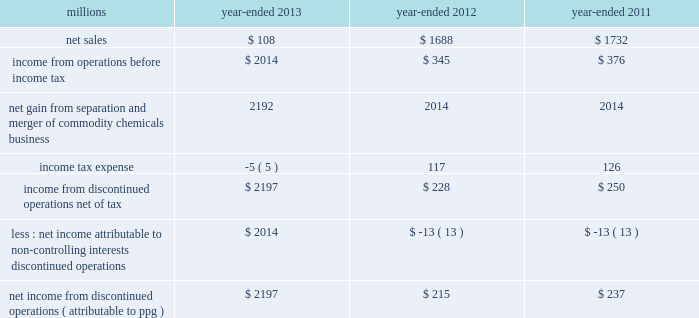74 2013 ppg annual report and form 10-k 22 .
Separation and merger transaction on january 28 , 2013 , the company completed the previously announced separation of its commodity chemicals business and merger of its wholly-owned subsidiary , eagle spinco inc. , with a subsidiary of georgia gulf corporation in a tax ef ficient reverse morris trust transaction ( the 201ctransaction 201d ) .
Pursuant to the merger , eagle spinco , the entity holding ppg's former commodity chemicals business , became a wholly-owned subsidiary of georgia gulf .
The closing of the merger followed the expiration of the related exchange offer and the satisfaction of certain other conditions .
The combined company formed by uniting georgia gulf with ppg's former commodity chemicals business is named axiall corporation ( 201caxiall 201d ) .
Ppg holds no ownership interest in axiall .
Ppg received the necessary ruling from the internal revenue service and as a result this transaction was generally tax free to ppg and its shareholders in the united states and canada .
Under the terms of the exchange offer , 35249104 shares of eagle spinco common stock were available for distribution in exchange for shares of ppg common stock accepted in the offer .
Following the merger , each share of eagle spinco common stock automatically converted into the right to receive one share of axiall corporation common stock .
Accordingly , ppg shareholders who tendered their shares of ppg common stock as part of this offer received 3.2562 shares of axiall common stock for each share of ppg common stock accepted for exchange .
Ppg was able to accept the maximum of 10825227 shares of ppg common stock for exchange in the offer , and thereby , reduced its outstanding shares by approximately 7% ( 7 % ) .
The completion of this exchange offer was a non-cash financing transaction , which resulted in an increase in "treasury stock" at a cost of $ 1.561 billion based on the ppg closing stock price on january 25 , 2013 .
Under the terms of the transaction , ppg received $ 900 million of cash and 35.2 million shares of axiall common stock ( market value of $ 1.8 billion on january 25 , 2013 ) which was distributed to ppg shareholders by the exchange offer as described above .
In addition , ppg received $ 67 million in cash for a preliminary post-closing working capital adjustment under the terms of the transaction agreements .
The net assets transferred to axiall included $ 27 million of cash on the books of the business transferred .
In the transaction , ppg transferred environmental remediation liabilities , defined benefit pension plan assets and liabilities and other post-employment benefit liabilities related to the commodity chemicals business to axiall .
During the first quarter of 2013 , ppg recorded a gain of $ 2.2 billion on the transaction reflecting the excess of the sum of the cash proceeds received and the cost ( closing stock price on january 25 , 2013 ) of the ppg shares tendered and accepted in the exchange for the 35.2 million shares of axiall common stock over the net book value of the net assets of ppg's former commodity chemicals business .
The transaction resulted in a net partial settlement loss of $ 33 million associated with the spin out and termination of defined benefit pension liabilities and the transfer of other post-retirement benefit liabilities under the terms of the transaction .
The company also incurred $ 14 million of pretax expense , primarily for professional services related to the transaction in 2013 as well as approximately $ 2 million of net expense related to certain retained obligations and post-closing adjustments under the terms of the transaction agreements .
The net gain on the transaction includes these related losses and expenses .
The results of operations and cash flows of ppg's former commodity chemicals business for january 2013 and the net gain on the transaction are reported as results from discontinued operations for the year -ended december 31 , 2013 .
In prior periods presented , the results of operations and cash flows of ppg's former commodity chemicals business have been reclassified from continuing operations and presented as results from discontinued operations .
Ppg will provide axiall with certain transition services for up to 24 months following the closing date of the transaction .
These services include logistics , purchasing , finance , information technology , human resources , tax and payroll processing .
The net sales and income before income taxes of the commodity chemicals business that have been reclassified and reported as discontinued operations are presented in the table below: .
Income from discontinued operations , net of tax $ 2197 $ 228 $ 250 less : net income attributable to non- controlling interests , discontinued operations $ 2014 $ ( 13 ) $ ( 13 ) net income from discontinued operations ( attributable to ppg ) $ 2197 $ 215 $ 237 during 2012 , $ 21 million of business separation costs are included within "income from discontinued operations , net." notes to the consolidated financial statements .
What was the change in millions of net sales for the commodity chemicals business that has been reclassified and reported as discontinued operations from 2011 to 2012? 
Computations: (1688 - 1732)
Answer: -44.0. 